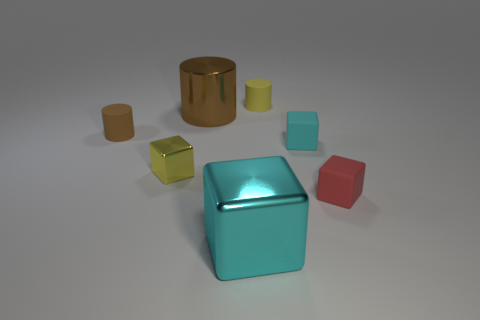Subtract all tiny blocks. How many blocks are left? 1 Subtract all red blocks. How many blocks are left? 3 Subtract all purple blocks. Subtract all gray spheres. How many blocks are left? 4 Add 2 gray spheres. How many objects exist? 9 Subtract all blocks. How many objects are left? 3 Subtract 0 red cylinders. How many objects are left? 7 Subtract all tiny red things. Subtract all cyan shiny things. How many objects are left? 5 Add 4 large cyan metal objects. How many large cyan metal objects are left? 5 Add 7 red cylinders. How many red cylinders exist? 7 